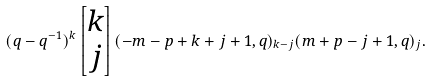Convert formula to latex. <formula><loc_0><loc_0><loc_500><loc_500>( q - q ^ { - 1 } ) ^ { k } \begin{bmatrix} k \\ j \end{bmatrix} ( - m - p + k + j + 1 , q ) _ { k - j } ( m + p - j + 1 , q ) _ { j } .</formula> 